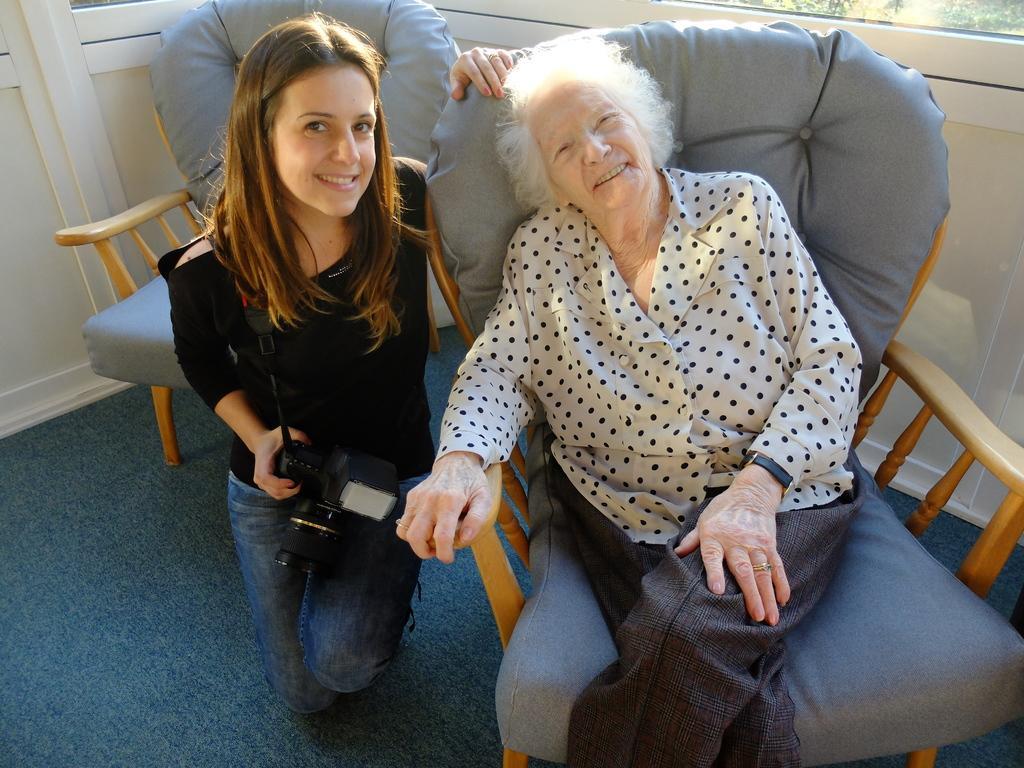Can you describe this image briefly? This is a picture taken in a room, there are two womens in this room. The women in white shirt sitting on a chair and the other women in black t shirt holding a camera. Background of this people is a wall which is in white color. 